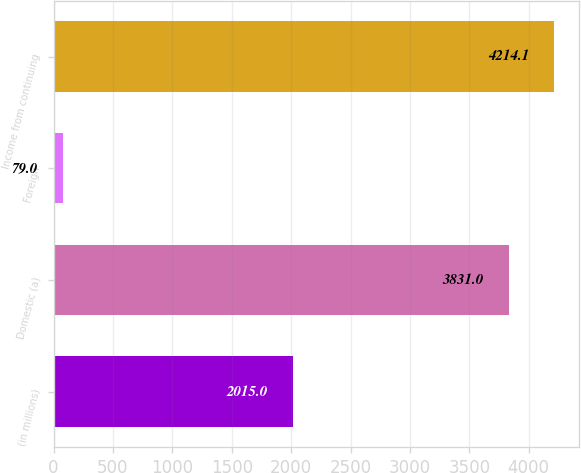Convert chart. <chart><loc_0><loc_0><loc_500><loc_500><bar_chart><fcel>(in millions)<fcel>Domestic (a)<fcel>Foreign<fcel>Income from continuing<nl><fcel>2015<fcel>3831<fcel>79<fcel>4214.1<nl></chart> 